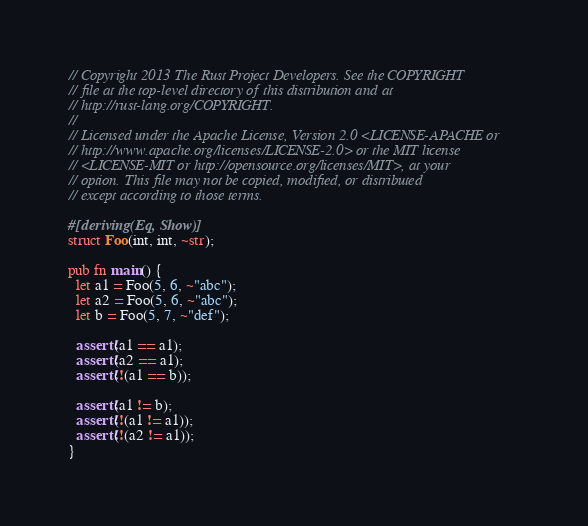<code> <loc_0><loc_0><loc_500><loc_500><_Rust_>// Copyright 2013 The Rust Project Developers. See the COPYRIGHT
// file at the top-level directory of this distribution and at
// http://rust-lang.org/COPYRIGHT.
//
// Licensed under the Apache License, Version 2.0 <LICENSE-APACHE or
// http://www.apache.org/licenses/LICENSE-2.0> or the MIT license
// <LICENSE-MIT or http://opensource.org/licenses/MIT>, at your
// option. This file may not be copied, modified, or distributed
// except according to those terms.

#[deriving(Eq, Show)]
struct Foo(int, int, ~str);

pub fn main() {
  let a1 = Foo(5, 6, ~"abc");
  let a2 = Foo(5, 6, ~"abc");
  let b = Foo(5, 7, ~"def");

  assert!(a1 == a1);
  assert!(a2 == a1);
  assert!(!(a1 == b));

  assert!(a1 != b);
  assert!(!(a1 != a1));
  assert!(!(a2 != a1));
}
</code> 